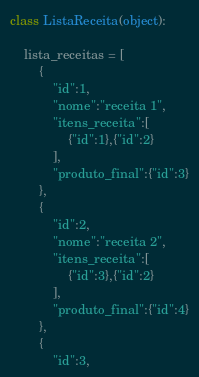<code> <loc_0><loc_0><loc_500><loc_500><_Python_>class ListaReceita(object):

    lista_receitas = [
        {
            "id":1,
            "nome":"receita 1",
            "itens_receita":[
                {"id":1},{"id":2}
            ],
            "produto_final":{"id":3}
        },
        {
            "id":2,
            "nome":"receita 2",
            "itens_receita":[
                {"id":3},{"id":2}
            ],
            "produto_final":{"id":4}
        },
        {
            "id":3,</code> 